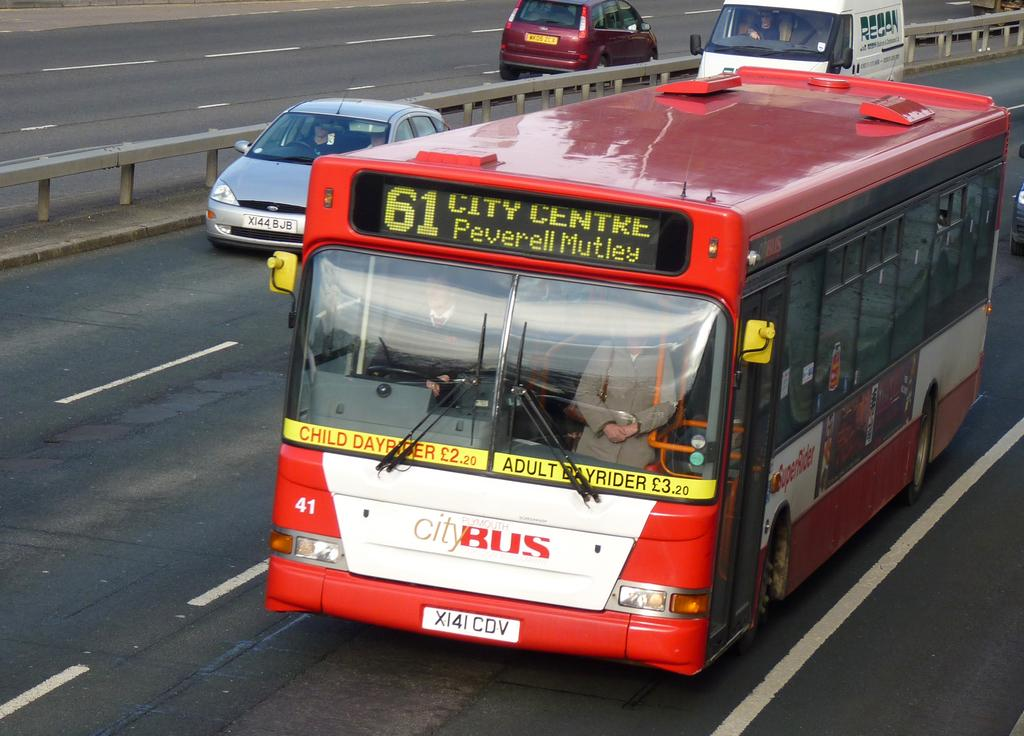What is the main feature of the image? There is a road in the image. What can be seen on the road? There are vehicles on the road. What type of vest is the road wearing in the image? There is no vest present in the image, as the subject is a road and not a person or animal. 